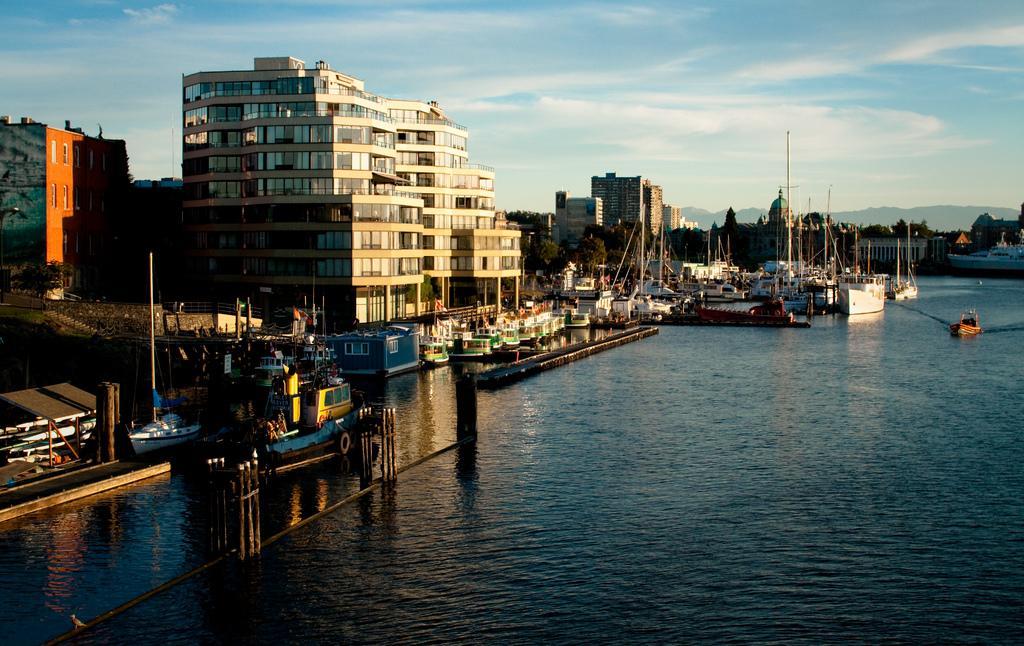Describe this image in one or two sentences. This image consists of buildings. At the bottom, we can see water and there are many boats in this image. At the top, there are clouds in the sky. 